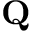<formula> <loc_0><loc_0><loc_500><loc_500>Q</formula> 